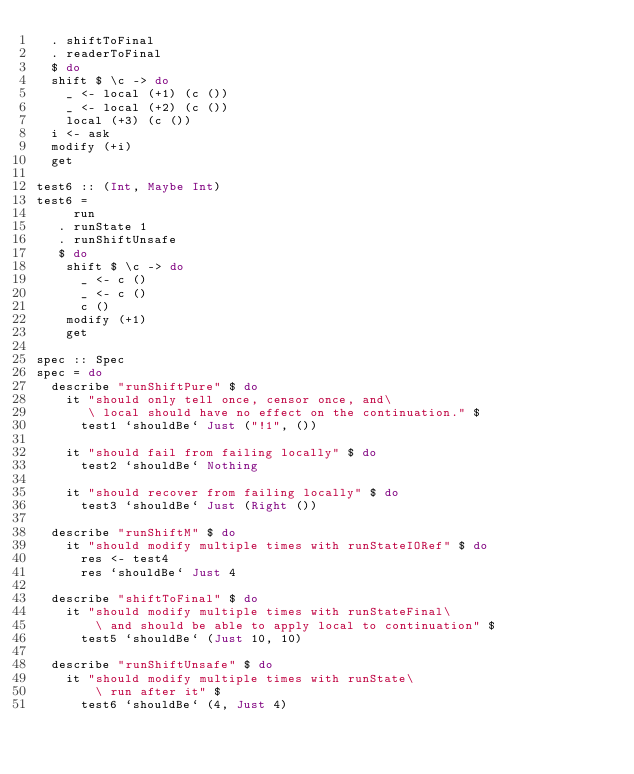<code> <loc_0><loc_0><loc_500><loc_500><_Haskell_>  . shiftToFinal
  . readerToFinal
  $ do
  shift $ \c -> do
    _ <- local (+1) (c ())
    _ <- local (+2) (c ())
    local (+3) (c ())
  i <- ask
  modify (+i)
  get

test6 :: (Int, Maybe Int)
test6 =
     run
   . runState 1
   . runShiftUnsafe
   $ do
    shift $ \c -> do
      _ <- c ()
      _ <- c ()
      c ()
    modify (+1)
    get

spec :: Spec
spec = do
  describe "runShiftPure" $ do
    it "should only tell once, censor once, and\
       \ local should have no effect on the continuation." $
      test1 `shouldBe` Just ("!1", ())

    it "should fail from failing locally" $ do
      test2 `shouldBe` Nothing

    it "should recover from failing locally" $ do
      test3 `shouldBe` Just (Right ())

  describe "runShiftM" $ do
    it "should modify multiple times with runStateIORef" $ do
      res <- test4
      res `shouldBe` Just 4

  describe "shiftToFinal" $ do
    it "should modify multiple times with runStateFinal\
        \ and should be able to apply local to continuation" $
      test5 `shouldBe` (Just 10, 10)

  describe "runShiftUnsafe" $ do
    it "should modify multiple times with runState\
        \ run after it" $
      test6 `shouldBe` (4, Just 4)
</code> 